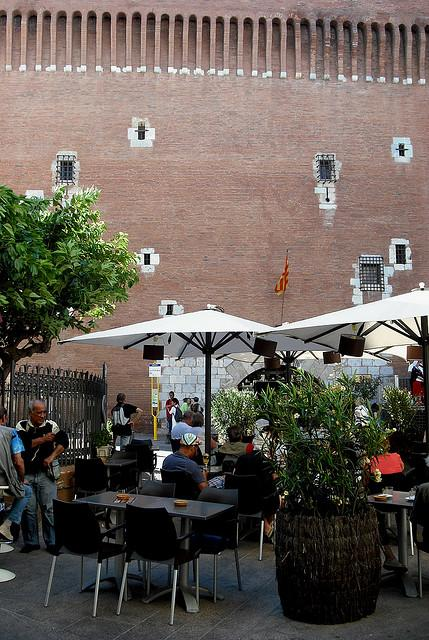Umbrellas provide what here? shade 